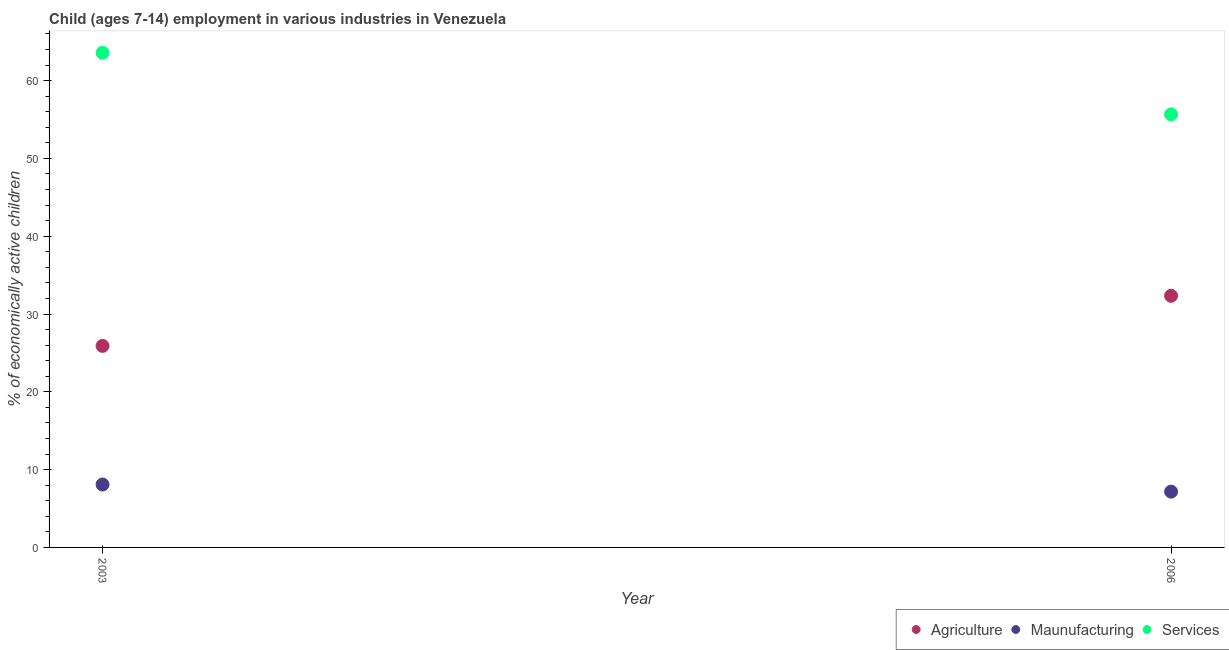What is the percentage of economically active children in agriculture in 2003?
Offer a terse response. 25.9. Across all years, what is the maximum percentage of economically active children in agriculture?
Give a very brief answer. 32.34. Across all years, what is the minimum percentage of economically active children in agriculture?
Your response must be concise. 25.9. What is the total percentage of economically active children in manufacturing in the graph?
Offer a terse response. 15.26. What is the difference between the percentage of economically active children in manufacturing in 2003 and that in 2006?
Make the answer very short. 0.92. What is the difference between the percentage of economically active children in agriculture in 2003 and the percentage of economically active children in services in 2006?
Keep it short and to the point. -29.76. What is the average percentage of economically active children in manufacturing per year?
Provide a short and direct response. 7.63. In the year 2006, what is the difference between the percentage of economically active children in agriculture and percentage of economically active children in manufacturing?
Provide a short and direct response. 25.17. In how many years, is the percentage of economically active children in manufacturing greater than 12 %?
Make the answer very short. 0. What is the ratio of the percentage of economically active children in manufacturing in 2003 to that in 2006?
Give a very brief answer. 1.13. Is the percentage of economically active children in services in 2003 less than that in 2006?
Give a very brief answer. No. In how many years, is the percentage of economically active children in manufacturing greater than the average percentage of economically active children in manufacturing taken over all years?
Offer a very short reply. 1. Is the percentage of economically active children in manufacturing strictly greater than the percentage of economically active children in agriculture over the years?
Your response must be concise. No. Is the percentage of economically active children in services strictly less than the percentage of economically active children in agriculture over the years?
Ensure brevity in your answer.  No. How many dotlines are there?
Your response must be concise. 3. How many years are there in the graph?
Provide a short and direct response. 2. What is the difference between two consecutive major ticks on the Y-axis?
Your response must be concise. 10. Where does the legend appear in the graph?
Your response must be concise. Bottom right. How are the legend labels stacked?
Provide a short and direct response. Horizontal. What is the title of the graph?
Provide a short and direct response. Child (ages 7-14) employment in various industries in Venezuela. Does "Injury" appear as one of the legend labels in the graph?
Give a very brief answer. No. What is the label or title of the X-axis?
Give a very brief answer. Year. What is the label or title of the Y-axis?
Offer a very short reply. % of economically active children. What is the % of economically active children in Agriculture in 2003?
Your answer should be compact. 25.9. What is the % of economically active children of Maunufacturing in 2003?
Keep it short and to the point. 8.09. What is the % of economically active children in Services in 2003?
Your answer should be compact. 63.57. What is the % of economically active children in Agriculture in 2006?
Offer a very short reply. 32.34. What is the % of economically active children of Maunufacturing in 2006?
Provide a short and direct response. 7.17. What is the % of economically active children in Services in 2006?
Provide a short and direct response. 55.66. Across all years, what is the maximum % of economically active children in Agriculture?
Give a very brief answer. 32.34. Across all years, what is the maximum % of economically active children of Maunufacturing?
Your answer should be compact. 8.09. Across all years, what is the maximum % of economically active children in Services?
Provide a succinct answer. 63.57. Across all years, what is the minimum % of economically active children in Agriculture?
Offer a very short reply. 25.9. Across all years, what is the minimum % of economically active children in Maunufacturing?
Keep it short and to the point. 7.17. Across all years, what is the minimum % of economically active children of Services?
Make the answer very short. 55.66. What is the total % of economically active children of Agriculture in the graph?
Make the answer very short. 58.24. What is the total % of economically active children in Maunufacturing in the graph?
Offer a very short reply. 15.26. What is the total % of economically active children in Services in the graph?
Give a very brief answer. 119.23. What is the difference between the % of economically active children in Agriculture in 2003 and that in 2006?
Give a very brief answer. -6.44. What is the difference between the % of economically active children in Maunufacturing in 2003 and that in 2006?
Your response must be concise. 0.92. What is the difference between the % of economically active children of Services in 2003 and that in 2006?
Offer a very short reply. 7.91. What is the difference between the % of economically active children in Agriculture in 2003 and the % of economically active children in Maunufacturing in 2006?
Keep it short and to the point. 18.73. What is the difference between the % of economically active children in Agriculture in 2003 and the % of economically active children in Services in 2006?
Your answer should be very brief. -29.76. What is the difference between the % of economically active children of Maunufacturing in 2003 and the % of economically active children of Services in 2006?
Offer a very short reply. -47.57. What is the average % of economically active children of Agriculture per year?
Your response must be concise. 29.12. What is the average % of economically active children of Maunufacturing per year?
Your answer should be compact. 7.63. What is the average % of economically active children of Services per year?
Make the answer very short. 59.62. In the year 2003, what is the difference between the % of economically active children in Agriculture and % of economically active children in Maunufacturing?
Make the answer very short. 17.81. In the year 2003, what is the difference between the % of economically active children of Agriculture and % of economically active children of Services?
Make the answer very short. -37.67. In the year 2003, what is the difference between the % of economically active children in Maunufacturing and % of economically active children in Services?
Offer a very short reply. -55.49. In the year 2006, what is the difference between the % of economically active children in Agriculture and % of economically active children in Maunufacturing?
Your response must be concise. 25.17. In the year 2006, what is the difference between the % of economically active children of Agriculture and % of economically active children of Services?
Make the answer very short. -23.32. In the year 2006, what is the difference between the % of economically active children of Maunufacturing and % of economically active children of Services?
Ensure brevity in your answer.  -48.49. What is the ratio of the % of economically active children in Agriculture in 2003 to that in 2006?
Provide a short and direct response. 0.8. What is the ratio of the % of economically active children in Maunufacturing in 2003 to that in 2006?
Keep it short and to the point. 1.13. What is the ratio of the % of economically active children in Services in 2003 to that in 2006?
Your answer should be compact. 1.14. What is the difference between the highest and the second highest % of economically active children of Agriculture?
Give a very brief answer. 6.44. What is the difference between the highest and the second highest % of economically active children in Maunufacturing?
Offer a terse response. 0.92. What is the difference between the highest and the second highest % of economically active children of Services?
Offer a terse response. 7.91. What is the difference between the highest and the lowest % of economically active children of Agriculture?
Offer a very short reply. 6.44. What is the difference between the highest and the lowest % of economically active children in Maunufacturing?
Ensure brevity in your answer.  0.92. What is the difference between the highest and the lowest % of economically active children of Services?
Provide a short and direct response. 7.91. 